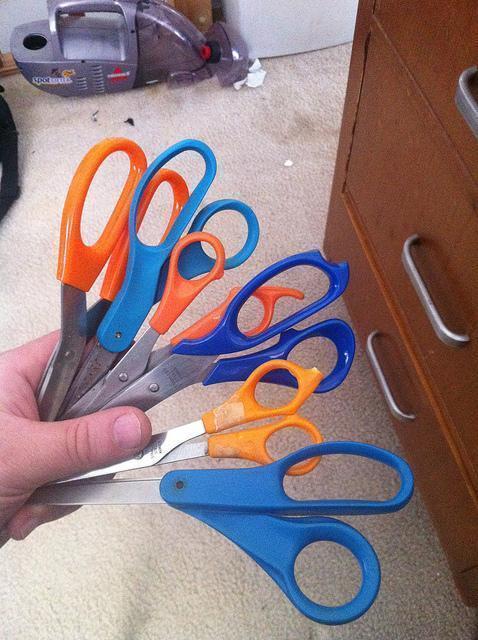What color is the smallest pair of scissors?
Select the accurate answer and provide justification: `Answer: choice
Rationale: srationale.`
Options: Pink, black, green, orange. Answer: orange.
Rationale: The smallest scissors are light orange. 